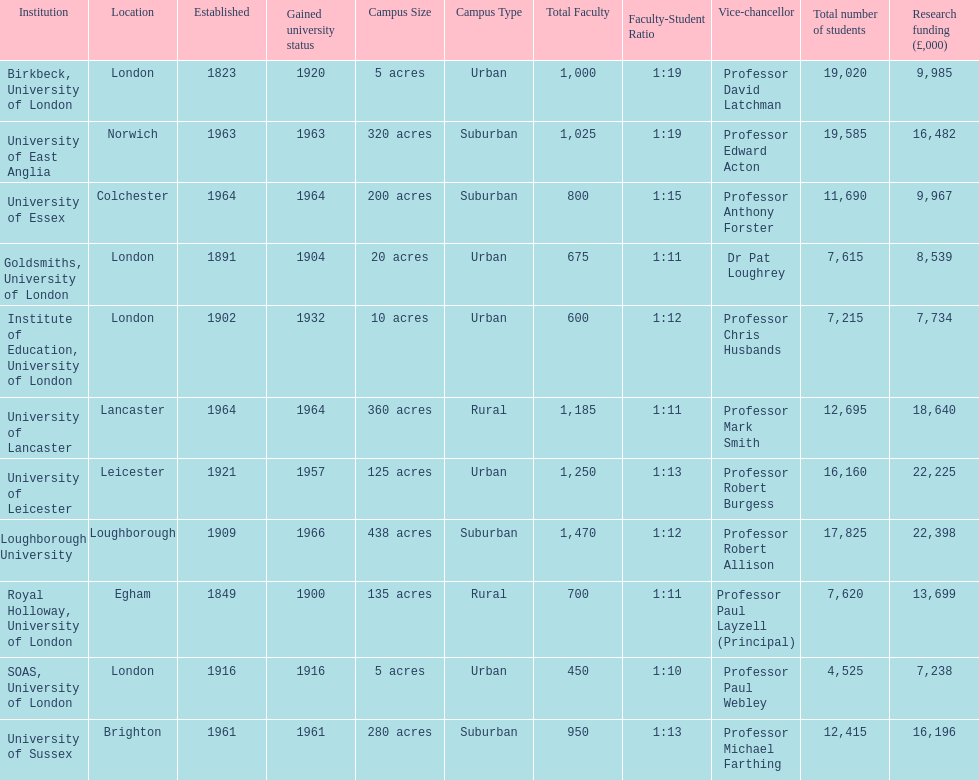Which institution has the most research funding? Loughborough University. 